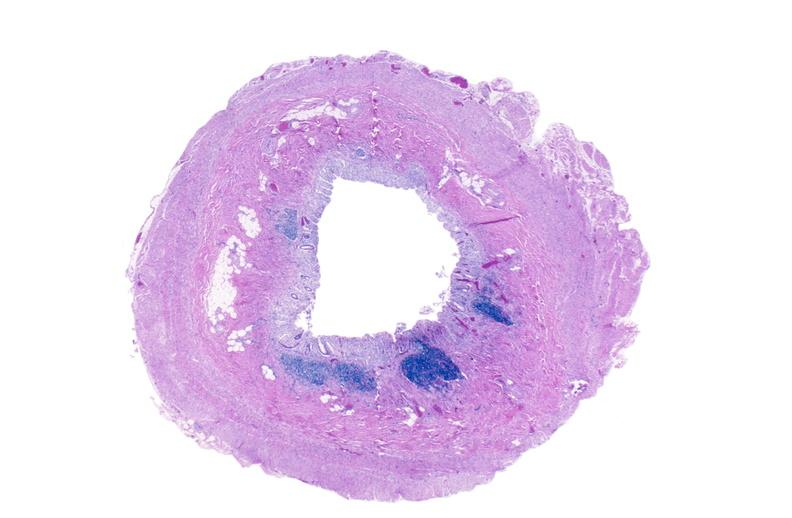does this image show normal appendix?
Answer the question using a single word or phrase. Yes 